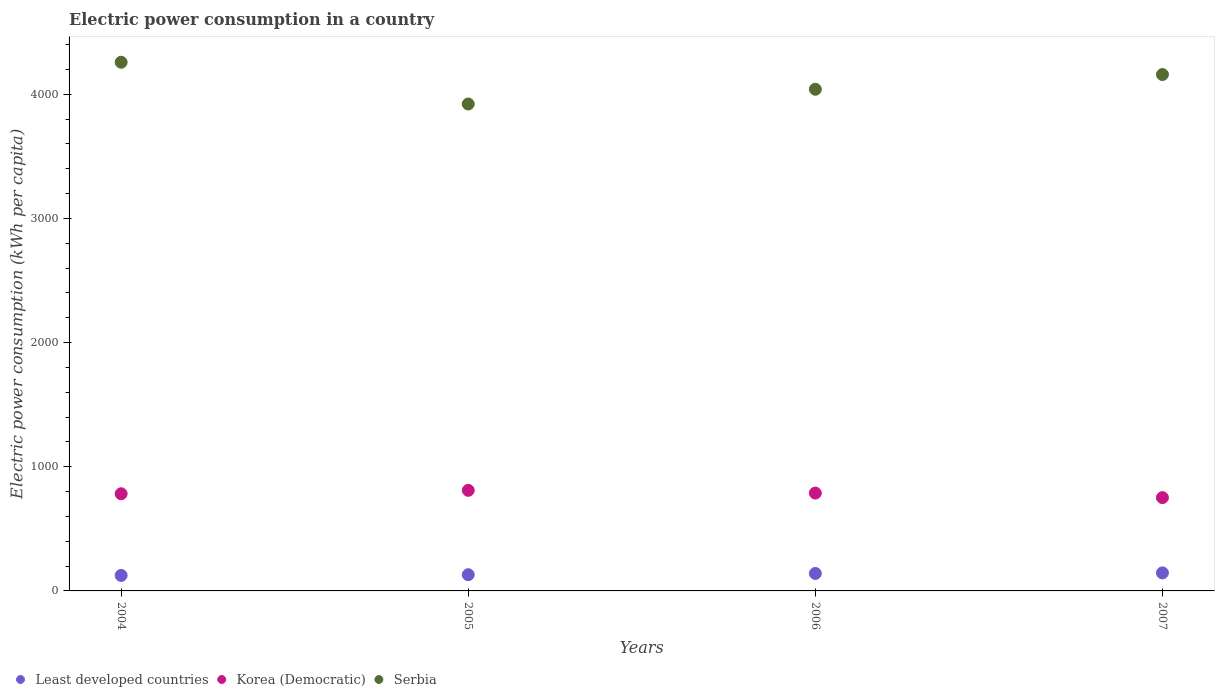What is the electric power consumption in in Korea (Democratic) in 2004?
Provide a succinct answer. 782.64. Across all years, what is the maximum electric power consumption in in Least developed countries?
Your answer should be very brief. 145.28. Across all years, what is the minimum electric power consumption in in Korea (Democratic)?
Provide a short and direct response. 751.54. In which year was the electric power consumption in in Korea (Democratic) maximum?
Ensure brevity in your answer.  2005. In which year was the electric power consumption in in Least developed countries minimum?
Provide a succinct answer. 2004. What is the total electric power consumption in in Korea (Democratic) in the graph?
Your answer should be very brief. 3132.38. What is the difference between the electric power consumption in in Serbia in 2004 and that in 2006?
Keep it short and to the point. 217.81. What is the difference between the electric power consumption in in Least developed countries in 2006 and the electric power consumption in in Serbia in 2005?
Keep it short and to the point. -3781.21. What is the average electric power consumption in in Serbia per year?
Your answer should be compact. 4094.93. In the year 2004, what is the difference between the electric power consumption in in Serbia and electric power consumption in in Korea (Democratic)?
Your answer should be compact. 3475.61. What is the ratio of the electric power consumption in in Least developed countries in 2006 to that in 2007?
Make the answer very short. 0.97. Is the electric power consumption in in Korea (Democratic) in 2004 less than that in 2007?
Your answer should be very brief. No. Is the difference between the electric power consumption in in Serbia in 2005 and 2007 greater than the difference between the electric power consumption in in Korea (Democratic) in 2005 and 2007?
Your answer should be very brief. No. What is the difference between the highest and the second highest electric power consumption in in Korea (Democratic)?
Make the answer very short. 22.06. What is the difference between the highest and the lowest electric power consumption in in Least developed countries?
Ensure brevity in your answer.  20.48. In how many years, is the electric power consumption in in Least developed countries greater than the average electric power consumption in in Least developed countries taken over all years?
Provide a succinct answer. 2. Is the sum of the electric power consumption in in Serbia in 2005 and 2007 greater than the maximum electric power consumption in in Korea (Democratic) across all years?
Give a very brief answer. Yes. Is the electric power consumption in in Korea (Democratic) strictly less than the electric power consumption in in Serbia over the years?
Your answer should be very brief. Yes. How many years are there in the graph?
Your answer should be very brief. 4. What is the difference between two consecutive major ticks on the Y-axis?
Provide a succinct answer. 1000. Are the values on the major ticks of Y-axis written in scientific E-notation?
Make the answer very short. No. Where does the legend appear in the graph?
Your answer should be compact. Bottom left. How many legend labels are there?
Offer a very short reply. 3. What is the title of the graph?
Provide a succinct answer. Electric power consumption in a country. Does "Tajikistan" appear as one of the legend labels in the graph?
Provide a short and direct response. No. What is the label or title of the Y-axis?
Keep it short and to the point. Electric power consumption (kWh per capita). What is the Electric power consumption (kWh per capita) of Least developed countries in 2004?
Your response must be concise. 124.8. What is the Electric power consumption (kWh per capita) of Korea (Democratic) in 2004?
Make the answer very short. 782.64. What is the Electric power consumption (kWh per capita) of Serbia in 2004?
Ensure brevity in your answer.  4258.25. What is the Electric power consumption (kWh per capita) of Least developed countries in 2005?
Ensure brevity in your answer.  130.66. What is the Electric power consumption (kWh per capita) of Korea (Democratic) in 2005?
Provide a short and direct response. 810.13. What is the Electric power consumption (kWh per capita) in Serbia in 2005?
Your answer should be very brief. 3921.91. What is the Electric power consumption (kWh per capita) in Least developed countries in 2006?
Give a very brief answer. 140.7. What is the Electric power consumption (kWh per capita) in Korea (Democratic) in 2006?
Ensure brevity in your answer.  788.07. What is the Electric power consumption (kWh per capita) of Serbia in 2006?
Provide a succinct answer. 4040.44. What is the Electric power consumption (kWh per capita) in Least developed countries in 2007?
Provide a succinct answer. 145.28. What is the Electric power consumption (kWh per capita) in Korea (Democratic) in 2007?
Your response must be concise. 751.54. What is the Electric power consumption (kWh per capita) in Serbia in 2007?
Provide a short and direct response. 4159.14. Across all years, what is the maximum Electric power consumption (kWh per capita) in Least developed countries?
Make the answer very short. 145.28. Across all years, what is the maximum Electric power consumption (kWh per capita) in Korea (Democratic)?
Your response must be concise. 810.13. Across all years, what is the maximum Electric power consumption (kWh per capita) in Serbia?
Your answer should be very brief. 4258.25. Across all years, what is the minimum Electric power consumption (kWh per capita) in Least developed countries?
Your answer should be very brief. 124.8. Across all years, what is the minimum Electric power consumption (kWh per capita) of Korea (Democratic)?
Your response must be concise. 751.54. Across all years, what is the minimum Electric power consumption (kWh per capita) of Serbia?
Offer a terse response. 3921.91. What is the total Electric power consumption (kWh per capita) of Least developed countries in the graph?
Offer a terse response. 541.44. What is the total Electric power consumption (kWh per capita) of Korea (Democratic) in the graph?
Make the answer very short. 3132.38. What is the total Electric power consumption (kWh per capita) in Serbia in the graph?
Provide a succinct answer. 1.64e+04. What is the difference between the Electric power consumption (kWh per capita) in Least developed countries in 2004 and that in 2005?
Provide a succinct answer. -5.86. What is the difference between the Electric power consumption (kWh per capita) of Korea (Democratic) in 2004 and that in 2005?
Offer a very short reply. -27.5. What is the difference between the Electric power consumption (kWh per capita) in Serbia in 2004 and that in 2005?
Your response must be concise. 336.35. What is the difference between the Electric power consumption (kWh per capita) in Least developed countries in 2004 and that in 2006?
Provide a short and direct response. -15.89. What is the difference between the Electric power consumption (kWh per capita) of Korea (Democratic) in 2004 and that in 2006?
Make the answer very short. -5.43. What is the difference between the Electric power consumption (kWh per capita) in Serbia in 2004 and that in 2006?
Offer a very short reply. 217.81. What is the difference between the Electric power consumption (kWh per capita) in Least developed countries in 2004 and that in 2007?
Your answer should be very brief. -20.48. What is the difference between the Electric power consumption (kWh per capita) of Korea (Democratic) in 2004 and that in 2007?
Your answer should be compact. 31.1. What is the difference between the Electric power consumption (kWh per capita) of Serbia in 2004 and that in 2007?
Provide a short and direct response. 99.11. What is the difference between the Electric power consumption (kWh per capita) of Least developed countries in 2005 and that in 2006?
Provide a short and direct response. -10.03. What is the difference between the Electric power consumption (kWh per capita) of Korea (Democratic) in 2005 and that in 2006?
Keep it short and to the point. 22.06. What is the difference between the Electric power consumption (kWh per capita) in Serbia in 2005 and that in 2006?
Offer a very short reply. -118.53. What is the difference between the Electric power consumption (kWh per capita) in Least developed countries in 2005 and that in 2007?
Provide a succinct answer. -14.62. What is the difference between the Electric power consumption (kWh per capita) of Korea (Democratic) in 2005 and that in 2007?
Your response must be concise. 58.6. What is the difference between the Electric power consumption (kWh per capita) in Serbia in 2005 and that in 2007?
Keep it short and to the point. -237.23. What is the difference between the Electric power consumption (kWh per capita) in Least developed countries in 2006 and that in 2007?
Ensure brevity in your answer.  -4.59. What is the difference between the Electric power consumption (kWh per capita) in Korea (Democratic) in 2006 and that in 2007?
Provide a succinct answer. 36.54. What is the difference between the Electric power consumption (kWh per capita) in Serbia in 2006 and that in 2007?
Offer a very short reply. -118.7. What is the difference between the Electric power consumption (kWh per capita) of Least developed countries in 2004 and the Electric power consumption (kWh per capita) of Korea (Democratic) in 2005?
Offer a very short reply. -685.33. What is the difference between the Electric power consumption (kWh per capita) of Least developed countries in 2004 and the Electric power consumption (kWh per capita) of Serbia in 2005?
Give a very brief answer. -3797.1. What is the difference between the Electric power consumption (kWh per capita) of Korea (Democratic) in 2004 and the Electric power consumption (kWh per capita) of Serbia in 2005?
Keep it short and to the point. -3139.27. What is the difference between the Electric power consumption (kWh per capita) in Least developed countries in 2004 and the Electric power consumption (kWh per capita) in Korea (Democratic) in 2006?
Your response must be concise. -663.27. What is the difference between the Electric power consumption (kWh per capita) of Least developed countries in 2004 and the Electric power consumption (kWh per capita) of Serbia in 2006?
Your answer should be very brief. -3915.64. What is the difference between the Electric power consumption (kWh per capita) of Korea (Democratic) in 2004 and the Electric power consumption (kWh per capita) of Serbia in 2006?
Provide a short and direct response. -3257.8. What is the difference between the Electric power consumption (kWh per capita) in Least developed countries in 2004 and the Electric power consumption (kWh per capita) in Korea (Democratic) in 2007?
Give a very brief answer. -626.73. What is the difference between the Electric power consumption (kWh per capita) in Least developed countries in 2004 and the Electric power consumption (kWh per capita) in Serbia in 2007?
Provide a succinct answer. -4034.34. What is the difference between the Electric power consumption (kWh per capita) in Korea (Democratic) in 2004 and the Electric power consumption (kWh per capita) in Serbia in 2007?
Offer a very short reply. -3376.5. What is the difference between the Electric power consumption (kWh per capita) of Least developed countries in 2005 and the Electric power consumption (kWh per capita) of Korea (Democratic) in 2006?
Keep it short and to the point. -657.41. What is the difference between the Electric power consumption (kWh per capita) of Least developed countries in 2005 and the Electric power consumption (kWh per capita) of Serbia in 2006?
Give a very brief answer. -3909.78. What is the difference between the Electric power consumption (kWh per capita) in Korea (Democratic) in 2005 and the Electric power consumption (kWh per capita) in Serbia in 2006?
Ensure brevity in your answer.  -3230.31. What is the difference between the Electric power consumption (kWh per capita) of Least developed countries in 2005 and the Electric power consumption (kWh per capita) of Korea (Democratic) in 2007?
Make the answer very short. -620.87. What is the difference between the Electric power consumption (kWh per capita) in Least developed countries in 2005 and the Electric power consumption (kWh per capita) in Serbia in 2007?
Provide a succinct answer. -4028.48. What is the difference between the Electric power consumption (kWh per capita) of Korea (Democratic) in 2005 and the Electric power consumption (kWh per capita) of Serbia in 2007?
Your answer should be compact. -3349. What is the difference between the Electric power consumption (kWh per capita) of Least developed countries in 2006 and the Electric power consumption (kWh per capita) of Korea (Democratic) in 2007?
Your response must be concise. -610.84. What is the difference between the Electric power consumption (kWh per capita) of Least developed countries in 2006 and the Electric power consumption (kWh per capita) of Serbia in 2007?
Provide a short and direct response. -4018.44. What is the difference between the Electric power consumption (kWh per capita) in Korea (Democratic) in 2006 and the Electric power consumption (kWh per capita) in Serbia in 2007?
Provide a succinct answer. -3371.07. What is the average Electric power consumption (kWh per capita) of Least developed countries per year?
Make the answer very short. 135.36. What is the average Electric power consumption (kWh per capita) of Korea (Democratic) per year?
Make the answer very short. 783.1. What is the average Electric power consumption (kWh per capita) in Serbia per year?
Your answer should be very brief. 4094.93. In the year 2004, what is the difference between the Electric power consumption (kWh per capita) in Least developed countries and Electric power consumption (kWh per capita) in Korea (Democratic)?
Your answer should be very brief. -657.84. In the year 2004, what is the difference between the Electric power consumption (kWh per capita) in Least developed countries and Electric power consumption (kWh per capita) in Serbia?
Give a very brief answer. -4133.45. In the year 2004, what is the difference between the Electric power consumption (kWh per capita) of Korea (Democratic) and Electric power consumption (kWh per capita) of Serbia?
Ensure brevity in your answer.  -3475.61. In the year 2005, what is the difference between the Electric power consumption (kWh per capita) in Least developed countries and Electric power consumption (kWh per capita) in Korea (Democratic)?
Offer a terse response. -679.47. In the year 2005, what is the difference between the Electric power consumption (kWh per capita) of Least developed countries and Electric power consumption (kWh per capita) of Serbia?
Provide a succinct answer. -3791.25. In the year 2005, what is the difference between the Electric power consumption (kWh per capita) in Korea (Democratic) and Electric power consumption (kWh per capita) in Serbia?
Offer a terse response. -3111.77. In the year 2006, what is the difference between the Electric power consumption (kWh per capita) of Least developed countries and Electric power consumption (kWh per capita) of Korea (Democratic)?
Provide a short and direct response. -647.38. In the year 2006, what is the difference between the Electric power consumption (kWh per capita) in Least developed countries and Electric power consumption (kWh per capita) in Serbia?
Your answer should be very brief. -3899.74. In the year 2006, what is the difference between the Electric power consumption (kWh per capita) of Korea (Democratic) and Electric power consumption (kWh per capita) of Serbia?
Your answer should be compact. -3252.37. In the year 2007, what is the difference between the Electric power consumption (kWh per capita) in Least developed countries and Electric power consumption (kWh per capita) in Korea (Democratic)?
Give a very brief answer. -606.26. In the year 2007, what is the difference between the Electric power consumption (kWh per capita) in Least developed countries and Electric power consumption (kWh per capita) in Serbia?
Your response must be concise. -4013.86. In the year 2007, what is the difference between the Electric power consumption (kWh per capita) in Korea (Democratic) and Electric power consumption (kWh per capita) in Serbia?
Provide a succinct answer. -3407.6. What is the ratio of the Electric power consumption (kWh per capita) in Least developed countries in 2004 to that in 2005?
Your answer should be very brief. 0.96. What is the ratio of the Electric power consumption (kWh per capita) of Korea (Democratic) in 2004 to that in 2005?
Offer a terse response. 0.97. What is the ratio of the Electric power consumption (kWh per capita) of Serbia in 2004 to that in 2005?
Keep it short and to the point. 1.09. What is the ratio of the Electric power consumption (kWh per capita) in Least developed countries in 2004 to that in 2006?
Your response must be concise. 0.89. What is the ratio of the Electric power consumption (kWh per capita) in Korea (Democratic) in 2004 to that in 2006?
Your answer should be very brief. 0.99. What is the ratio of the Electric power consumption (kWh per capita) in Serbia in 2004 to that in 2006?
Your answer should be very brief. 1.05. What is the ratio of the Electric power consumption (kWh per capita) of Least developed countries in 2004 to that in 2007?
Your answer should be very brief. 0.86. What is the ratio of the Electric power consumption (kWh per capita) of Korea (Democratic) in 2004 to that in 2007?
Your answer should be very brief. 1.04. What is the ratio of the Electric power consumption (kWh per capita) in Serbia in 2004 to that in 2007?
Give a very brief answer. 1.02. What is the ratio of the Electric power consumption (kWh per capita) of Least developed countries in 2005 to that in 2006?
Offer a terse response. 0.93. What is the ratio of the Electric power consumption (kWh per capita) in Korea (Democratic) in 2005 to that in 2006?
Offer a very short reply. 1.03. What is the ratio of the Electric power consumption (kWh per capita) of Serbia in 2005 to that in 2006?
Offer a very short reply. 0.97. What is the ratio of the Electric power consumption (kWh per capita) of Least developed countries in 2005 to that in 2007?
Your answer should be very brief. 0.9. What is the ratio of the Electric power consumption (kWh per capita) of Korea (Democratic) in 2005 to that in 2007?
Keep it short and to the point. 1.08. What is the ratio of the Electric power consumption (kWh per capita) of Serbia in 2005 to that in 2007?
Make the answer very short. 0.94. What is the ratio of the Electric power consumption (kWh per capita) in Least developed countries in 2006 to that in 2007?
Your response must be concise. 0.97. What is the ratio of the Electric power consumption (kWh per capita) of Korea (Democratic) in 2006 to that in 2007?
Offer a very short reply. 1.05. What is the ratio of the Electric power consumption (kWh per capita) of Serbia in 2006 to that in 2007?
Ensure brevity in your answer.  0.97. What is the difference between the highest and the second highest Electric power consumption (kWh per capita) in Least developed countries?
Make the answer very short. 4.59. What is the difference between the highest and the second highest Electric power consumption (kWh per capita) in Korea (Democratic)?
Ensure brevity in your answer.  22.06. What is the difference between the highest and the second highest Electric power consumption (kWh per capita) in Serbia?
Your answer should be very brief. 99.11. What is the difference between the highest and the lowest Electric power consumption (kWh per capita) of Least developed countries?
Give a very brief answer. 20.48. What is the difference between the highest and the lowest Electric power consumption (kWh per capita) of Korea (Democratic)?
Ensure brevity in your answer.  58.6. What is the difference between the highest and the lowest Electric power consumption (kWh per capita) in Serbia?
Your answer should be very brief. 336.35. 